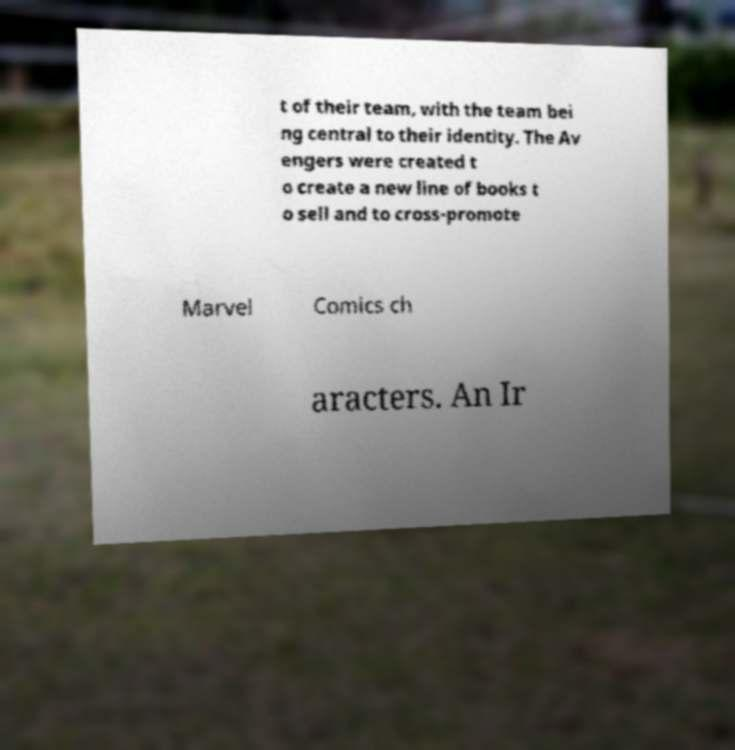There's text embedded in this image that I need extracted. Can you transcribe it verbatim? t of their team, with the team bei ng central to their identity. The Av engers were created t o create a new line of books t o sell and to cross-promote Marvel Comics ch aracters. An Ir 